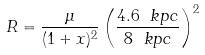<formula> <loc_0><loc_0><loc_500><loc_500>R = \frac { \mu } { ( 1 + x ) ^ { 2 } } \left ( \frac { 4 . 6 \ k p c } { 8 \ k p c } \right ) ^ { 2 }</formula> 